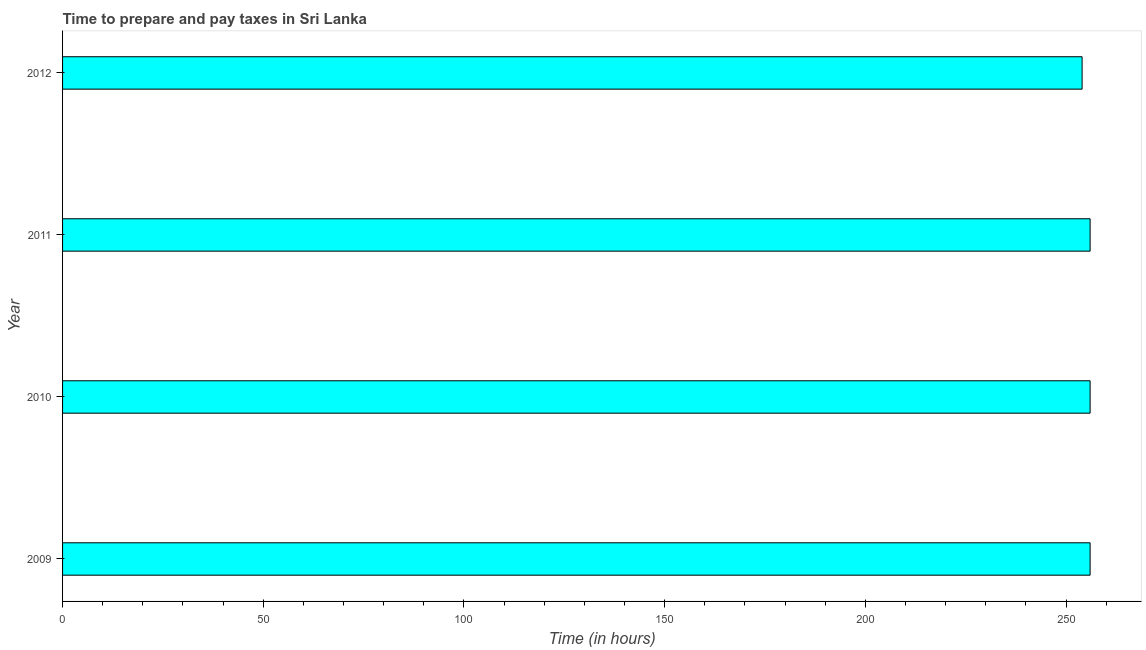Does the graph contain grids?
Offer a terse response. No. What is the title of the graph?
Your answer should be compact. Time to prepare and pay taxes in Sri Lanka. What is the label or title of the X-axis?
Give a very brief answer. Time (in hours). What is the label or title of the Y-axis?
Provide a short and direct response. Year. What is the time to prepare and pay taxes in 2011?
Keep it short and to the point. 256. Across all years, what is the maximum time to prepare and pay taxes?
Ensure brevity in your answer.  256. Across all years, what is the minimum time to prepare and pay taxes?
Provide a short and direct response. 254. In which year was the time to prepare and pay taxes maximum?
Offer a terse response. 2009. What is the sum of the time to prepare and pay taxes?
Your answer should be very brief. 1022. What is the difference between the time to prepare and pay taxes in 2011 and 2012?
Provide a short and direct response. 2. What is the average time to prepare and pay taxes per year?
Your answer should be compact. 255.5. What is the median time to prepare and pay taxes?
Offer a very short reply. 256. Do a majority of the years between 2010 and 2012 (inclusive) have time to prepare and pay taxes greater than 110 hours?
Ensure brevity in your answer.  Yes. What is the ratio of the time to prepare and pay taxes in 2010 to that in 2012?
Give a very brief answer. 1.01. Is the time to prepare and pay taxes in 2010 less than that in 2011?
Your answer should be compact. No. Is the difference between the time to prepare and pay taxes in 2009 and 2010 greater than the difference between any two years?
Provide a short and direct response. No. What is the difference between the highest and the second highest time to prepare and pay taxes?
Provide a succinct answer. 0. Is the sum of the time to prepare and pay taxes in 2010 and 2011 greater than the maximum time to prepare and pay taxes across all years?
Offer a very short reply. Yes. What is the Time (in hours) in 2009?
Offer a terse response. 256. What is the Time (in hours) in 2010?
Your answer should be very brief. 256. What is the Time (in hours) in 2011?
Make the answer very short. 256. What is the Time (in hours) in 2012?
Offer a terse response. 254. What is the difference between the Time (in hours) in 2009 and 2012?
Give a very brief answer. 2. What is the difference between the Time (in hours) in 2010 and 2011?
Make the answer very short. 0. What is the difference between the Time (in hours) in 2011 and 2012?
Your response must be concise. 2. What is the ratio of the Time (in hours) in 2009 to that in 2011?
Ensure brevity in your answer.  1. What is the ratio of the Time (in hours) in 2009 to that in 2012?
Provide a short and direct response. 1.01. What is the ratio of the Time (in hours) in 2010 to that in 2011?
Keep it short and to the point. 1. What is the ratio of the Time (in hours) in 2011 to that in 2012?
Your answer should be compact. 1.01. 